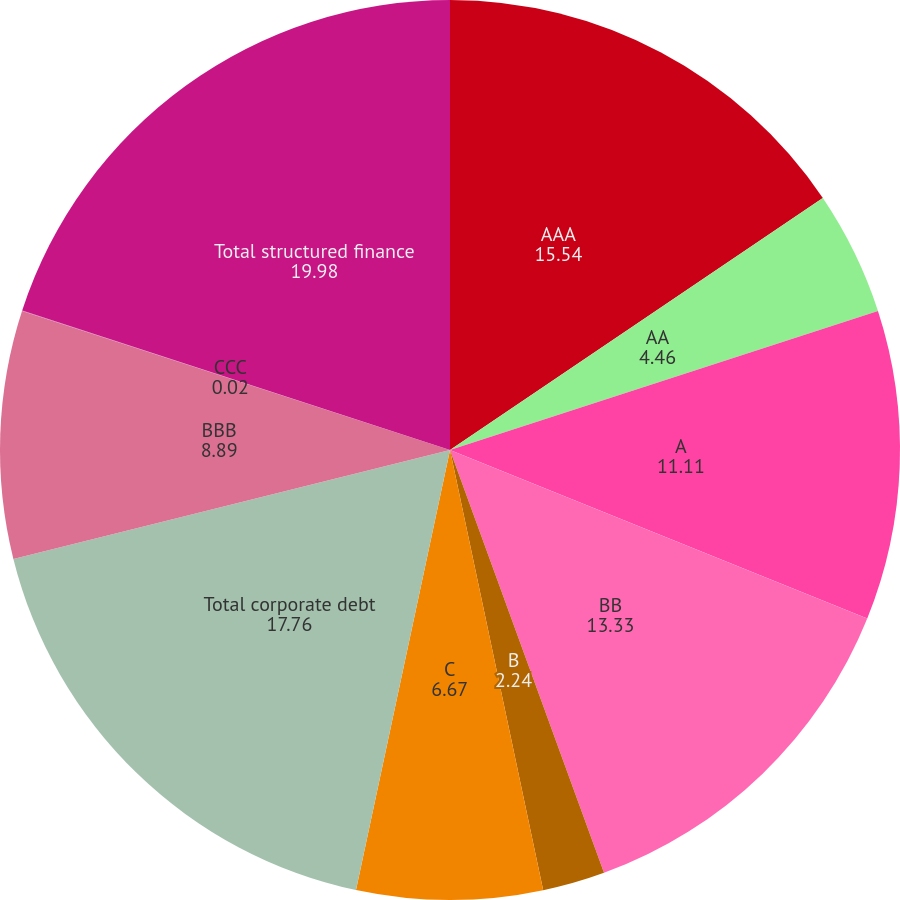Convert chart. <chart><loc_0><loc_0><loc_500><loc_500><pie_chart><fcel>AAA<fcel>AA<fcel>A<fcel>BB<fcel>B<fcel>C<fcel>Total corporate debt<fcel>BBB<fcel>CCC<fcel>Total structured finance<nl><fcel>15.54%<fcel>4.46%<fcel>11.11%<fcel>13.33%<fcel>2.24%<fcel>6.67%<fcel>17.76%<fcel>8.89%<fcel>0.02%<fcel>19.98%<nl></chart> 